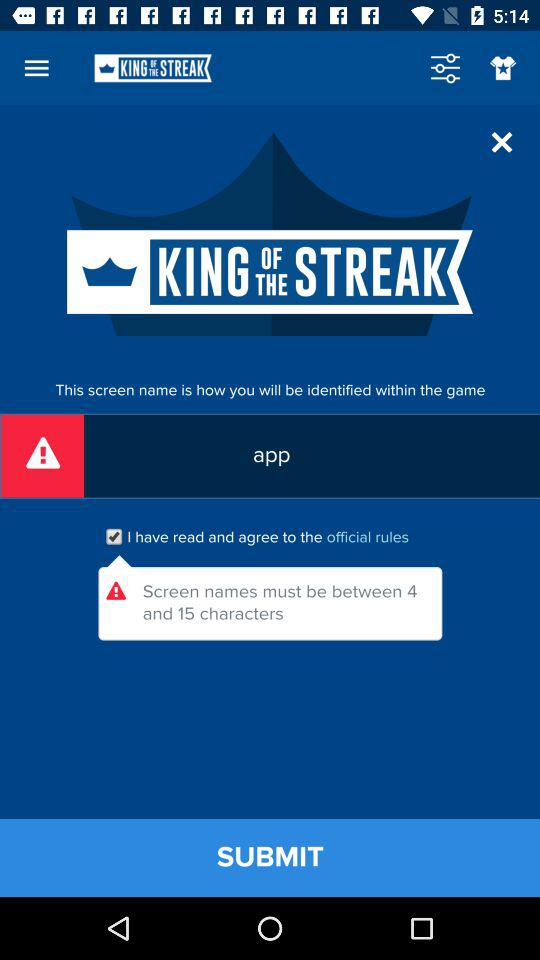Which checkbox has been selected? The selected checkbox is "I have read and agree to the official rules". 